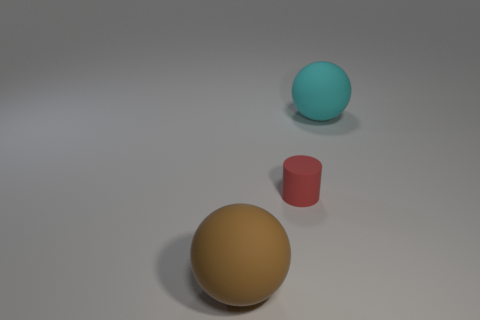Add 2 cyan rubber objects. How many objects exist? 5 Subtract all balls. How many objects are left? 1 Subtract 1 cylinders. How many cylinders are left? 0 Subtract all cyan balls. Subtract all cyan cylinders. How many balls are left? 1 Subtract all purple blocks. How many brown balls are left? 1 Subtract all tiny blue cylinders. Subtract all brown rubber balls. How many objects are left? 2 Add 1 small rubber things. How many small rubber things are left? 2 Add 2 tiny cylinders. How many tiny cylinders exist? 3 Subtract 1 red cylinders. How many objects are left? 2 